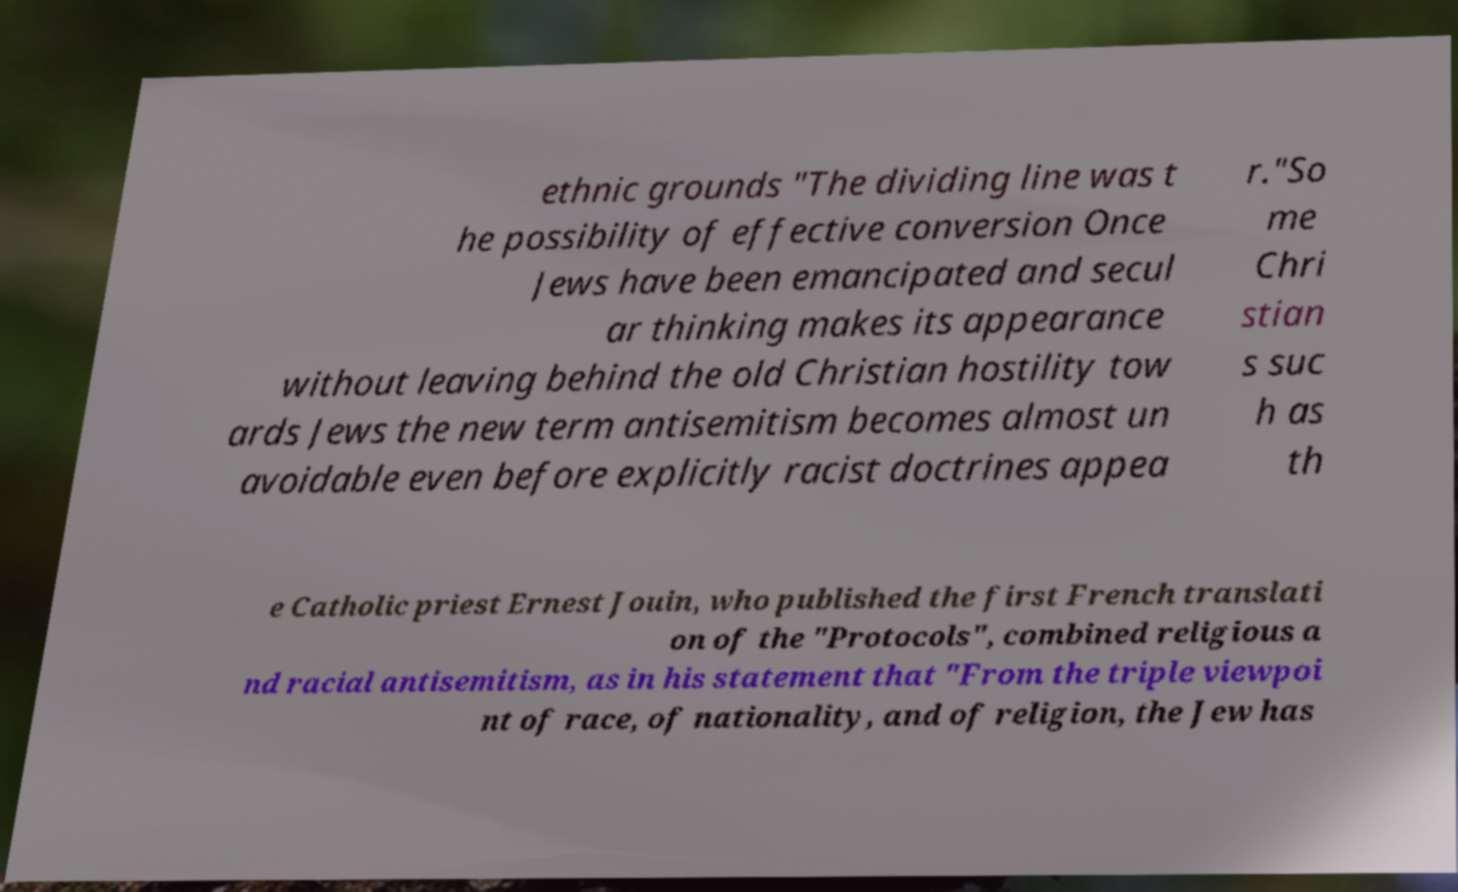Please read and relay the text visible in this image. What does it say? ethnic grounds "The dividing line was t he possibility of effective conversion Once Jews have been emancipated and secul ar thinking makes its appearance without leaving behind the old Christian hostility tow ards Jews the new term antisemitism becomes almost un avoidable even before explicitly racist doctrines appea r."So me Chri stian s suc h as th e Catholic priest Ernest Jouin, who published the first French translati on of the "Protocols", combined religious a nd racial antisemitism, as in his statement that "From the triple viewpoi nt of race, of nationality, and of religion, the Jew has 